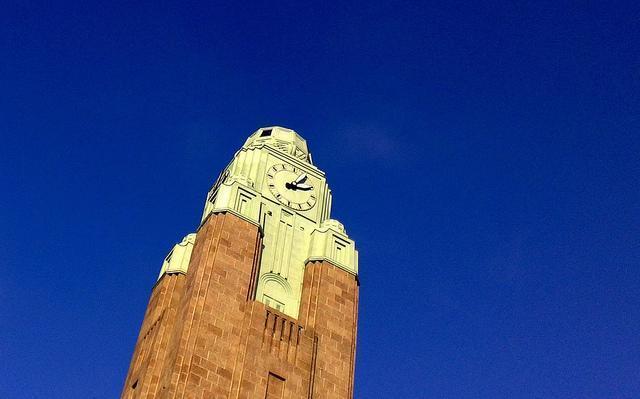How many clock hands are there?
Give a very brief answer. 2. How many cats are in this picture?
Give a very brief answer. 0. 